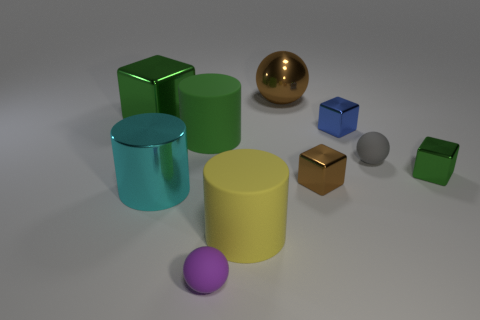Are any tiny red rubber cubes visible? No, there are no tiny red rubber cubes visible in the image. The objects present include a green cube and cylinder, a teal cylinder, a yellow cylinder, a purple sphere, a golden sphere, a blue cube, a bronze cube, and a gray sphere, all situated on a flat surface. 